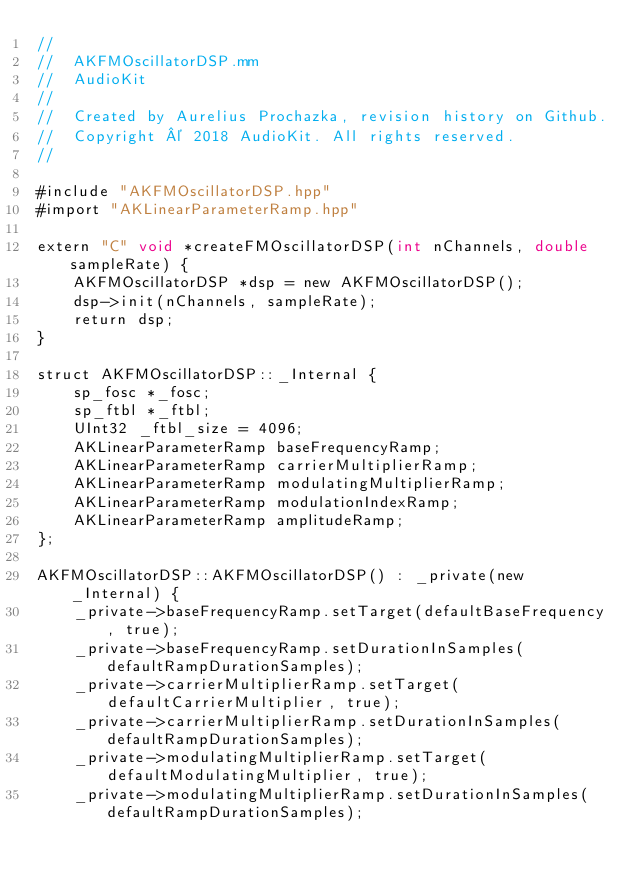<code> <loc_0><loc_0><loc_500><loc_500><_ObjectiveC_>//
//  AKFMOscillatorDSP.mm
//  AudioKit
//
//  Created by Aurelius Prochazka, revision history on Github.
//  Copyright © 2018 AudioKit. All rights reserved.
//

#include "AKFMOscillatorDSP.hpp"
#import "AKLinearParameterRamp.hpp"

extern "C" void *createFMOscillatorDSP(int nChannels, double sampleRate) {
    AKFMOscillatorDSP *dsp = new AKFMOscillatorDSP();
    dsp->init(nChannels, sampleRate);
    return dsp;
}

struct AKFMOscillatorDSP::_Internal {
    sp_fosc *_fosc;
    sp_ftbl *_ftbl;
    UInt32 _ftbl_size = 4096;
    AKLinearParameterRamp baseFrequencyRamp;
    AKLinearParameterRamp carrierMultiplierRamp;
    AKLinearParameterRamp modulatingMultiplierRamp;
    AKLinearParameterRamp modulationIndexRamp;
    AKLinearParameterRamp amplitudeRamp;
};

AKFMOscillatorDSP::AKFMOscillatorDSP() : _private(new _Internal) {
    _private->baseFrequencyRamp.setTarget(defaultBaseFrequency, true);
    _private->baseFrequencyRamp.setDurationInSamples(defaultRampDurationSamples);
    _private->carrierMultiplierRamp.setTarget(defaultCarrierMultiplier, true);
    _private->carrierMultiplierRamp.setDurationInSamples(defaultRampDurationSamples);
    _private->modulatingMultiplierRamp.setTarget(defaultModulatingMultiplier, true);
    _private->modulatingMultiplierRamp.setDurationInSamples(defaultRampDurationSamples);</code> 